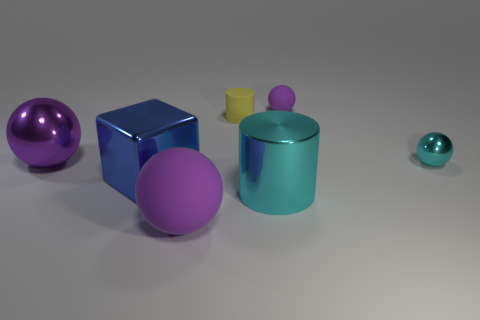Subtract all purple balls. How many were subtracted if there are1purple balls left? 2 Subtract all cyan metal balls. How many balls are left? 3 Add 2 big rubber spheres. How many objects exist? 9 Subtract all cyan spheres. How many spheres are left? 3 Subtract all cylinders. How many objects are left? 5 Subtract all gray spheres. How many yellow cylinders are left? 1 Add 7 big blue metallic balls. How many big blue metallic balls exist? 7 Subtract 0 gray cubes. How many objects are left? 7 Subtract 1 cylinders. How many cylinders are left? 1 Subtract all gray cubes. Subtract all yellow spheres. How many cubes are left? 1 